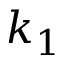Convert formula to latex. <formula><loc_0><loc_0><loc_500><loc_500>k _ { 1 }</formula> 